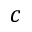Convert formula to latex. <formula><loc_0><loc_0><loc_500><loc_500>c</formula> 